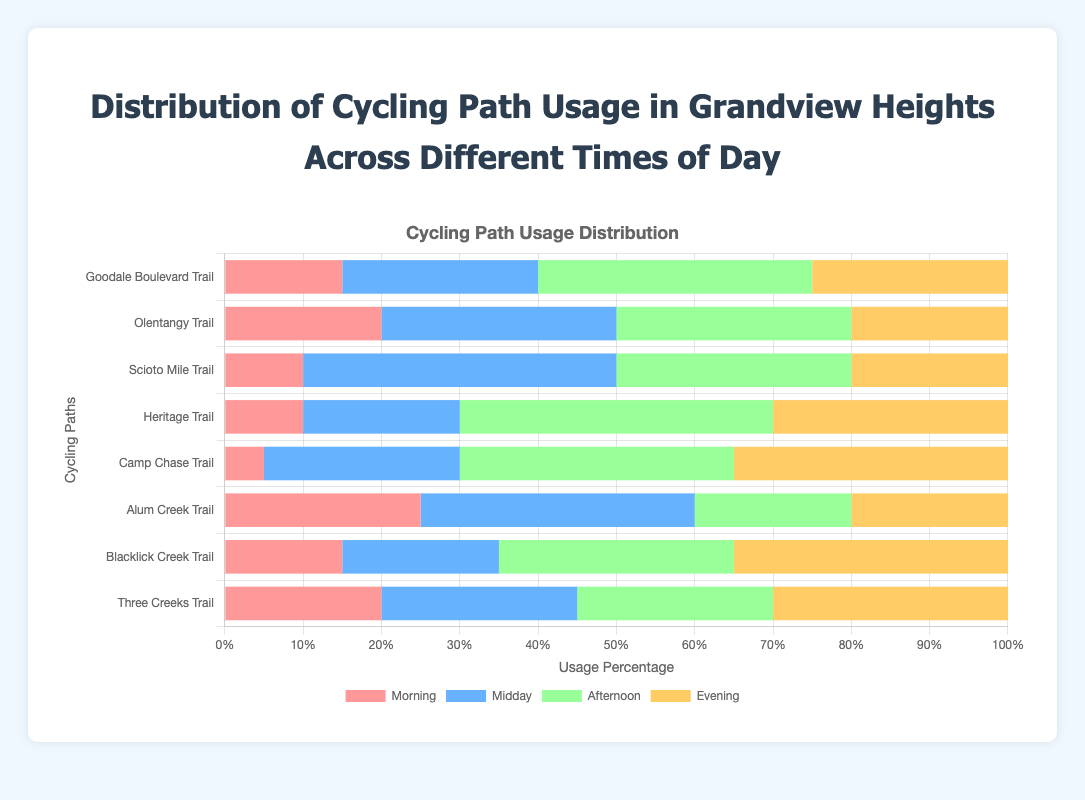Which cycling path has the highest usage in the morning? To find the highest usage in the morning, compare the morning values for each path. Alum Creek Trail has 25, the highest among all paths.
Answer: Alum Creek Trail Which cycling path has the least usage in the evening? Compare the evening usage for each path. Goodale Boulevard Trail and Olentangy Trail both have the least usage with 20 each.
Answer: Goodale Boulevard Trail and Olentangy Trail What is the total usage percentage for Olentangy Trail across all times of day? Sum the usage percentages for Olentangy Trail: 20 (morning) + 30 (midday) + 30 (afternoon) + 20 (evening) = 100.
Answer: 100 Which time of day has the highest combined usage for all trails? Sum the usage percentages for each time of day: Morning (120), Midday (220), Afternoon (245), Evening (205). Afternoon has the highest combined usage.
Answer: Afternoon Which trail shows the most balanced usage across different times of day? Look for the trail with the least variation in usage across the times. Goodale Boulevard Trail varies between 15 and 35, showing balanced usage.
Answer: Goodale Boulevard Trail Which cycling path has the highest usage in the afternoon and the lowest in the morning? Check the afternoon values for the highest usage, then ensure the same path has the lowest morning value. Heritage Trail has the highest afternoon usage (40) and a relatively low morning value (10).
Answer: Heritage Trail What is the difference in midday usage between the Alum Creek Trail and Heritage Trail? Subtract Heritage Trail's midday usage from Alum Creek Trail's: 35 (Alum Creek Trail) - 20 (Heritage Trail) = 15.
Answer: 15 Which two cycling paths have exactly the same morning usage? Look for two paths with matching morning usage values. Goodale Boulevard Trail and Blacklick Creek Trail both have a morning usage of 15.
Answer: Goodale Boulevard Trail and Blacklick Creek Trail What is the combined usage percentage for Blacklick Creek Trail during midday and evening? Sum the midday and evening values for Blacklick Creek Trail: 20 (midday) + 35 (evening) = 55.
Answer: 55 Which trail has the longest bar segment in the evening color (yellow)? Compare the bar lengths in the evening segment. Camp Chase Trail has the longest yellow bar with a usage of 35.
Answer: Camp Chase Trail 